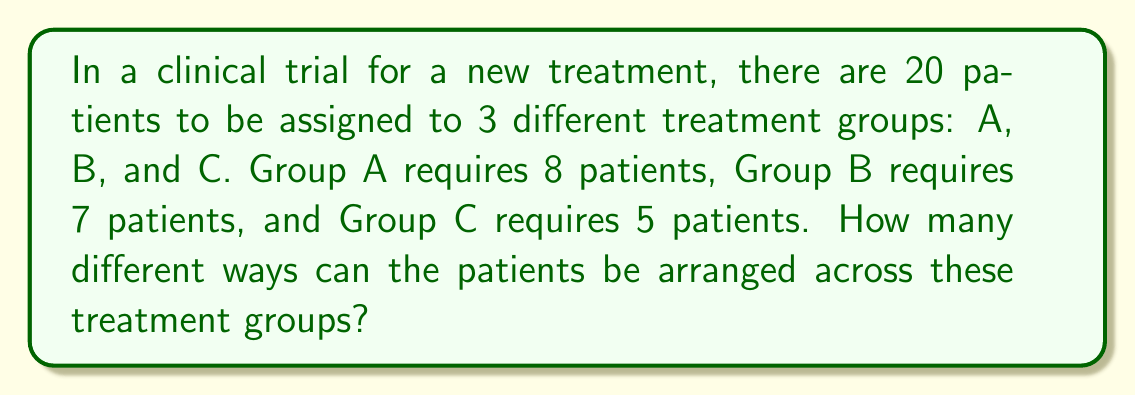Can you solve this math problem? To solve this problem, we need to use the concept of multinomial coefficients, which is an extension of combinations for multiple groups.

1. We have a total of 20 patients to be distributed among 3 groups.
2. The distribution is: 8 patients in Group A, 7 patients in Group B, and 5 patients in Group C.

The formula for multinomial coefficient is:

$$ \binom{n}{n_1, n_2, ..., n_k} = \frac{n!}{n_1! \cdot n_2! \cdot ... \cdot n_k!} $$

Where:
- $n$ is the total number of items (patients in this case)
- $n_1, n_2, ..., n_k$ are the number of items in each group

Substituting our values:

$$ \binom{20}{8, 7, 5} = \frac{20!}{8! \cdot 7! \cdot 5!} $$

Calculating this:

$$ \frac{20!}{8! \cdot 7! \cdot 5!} = \frac{2432902008176640000}{40320 \cdot 5040 \cdot 120} = 125970 $$

Therefore, there are 125,970 different ways to arrange the patients across the treatment groups.
Answer: 125,970 